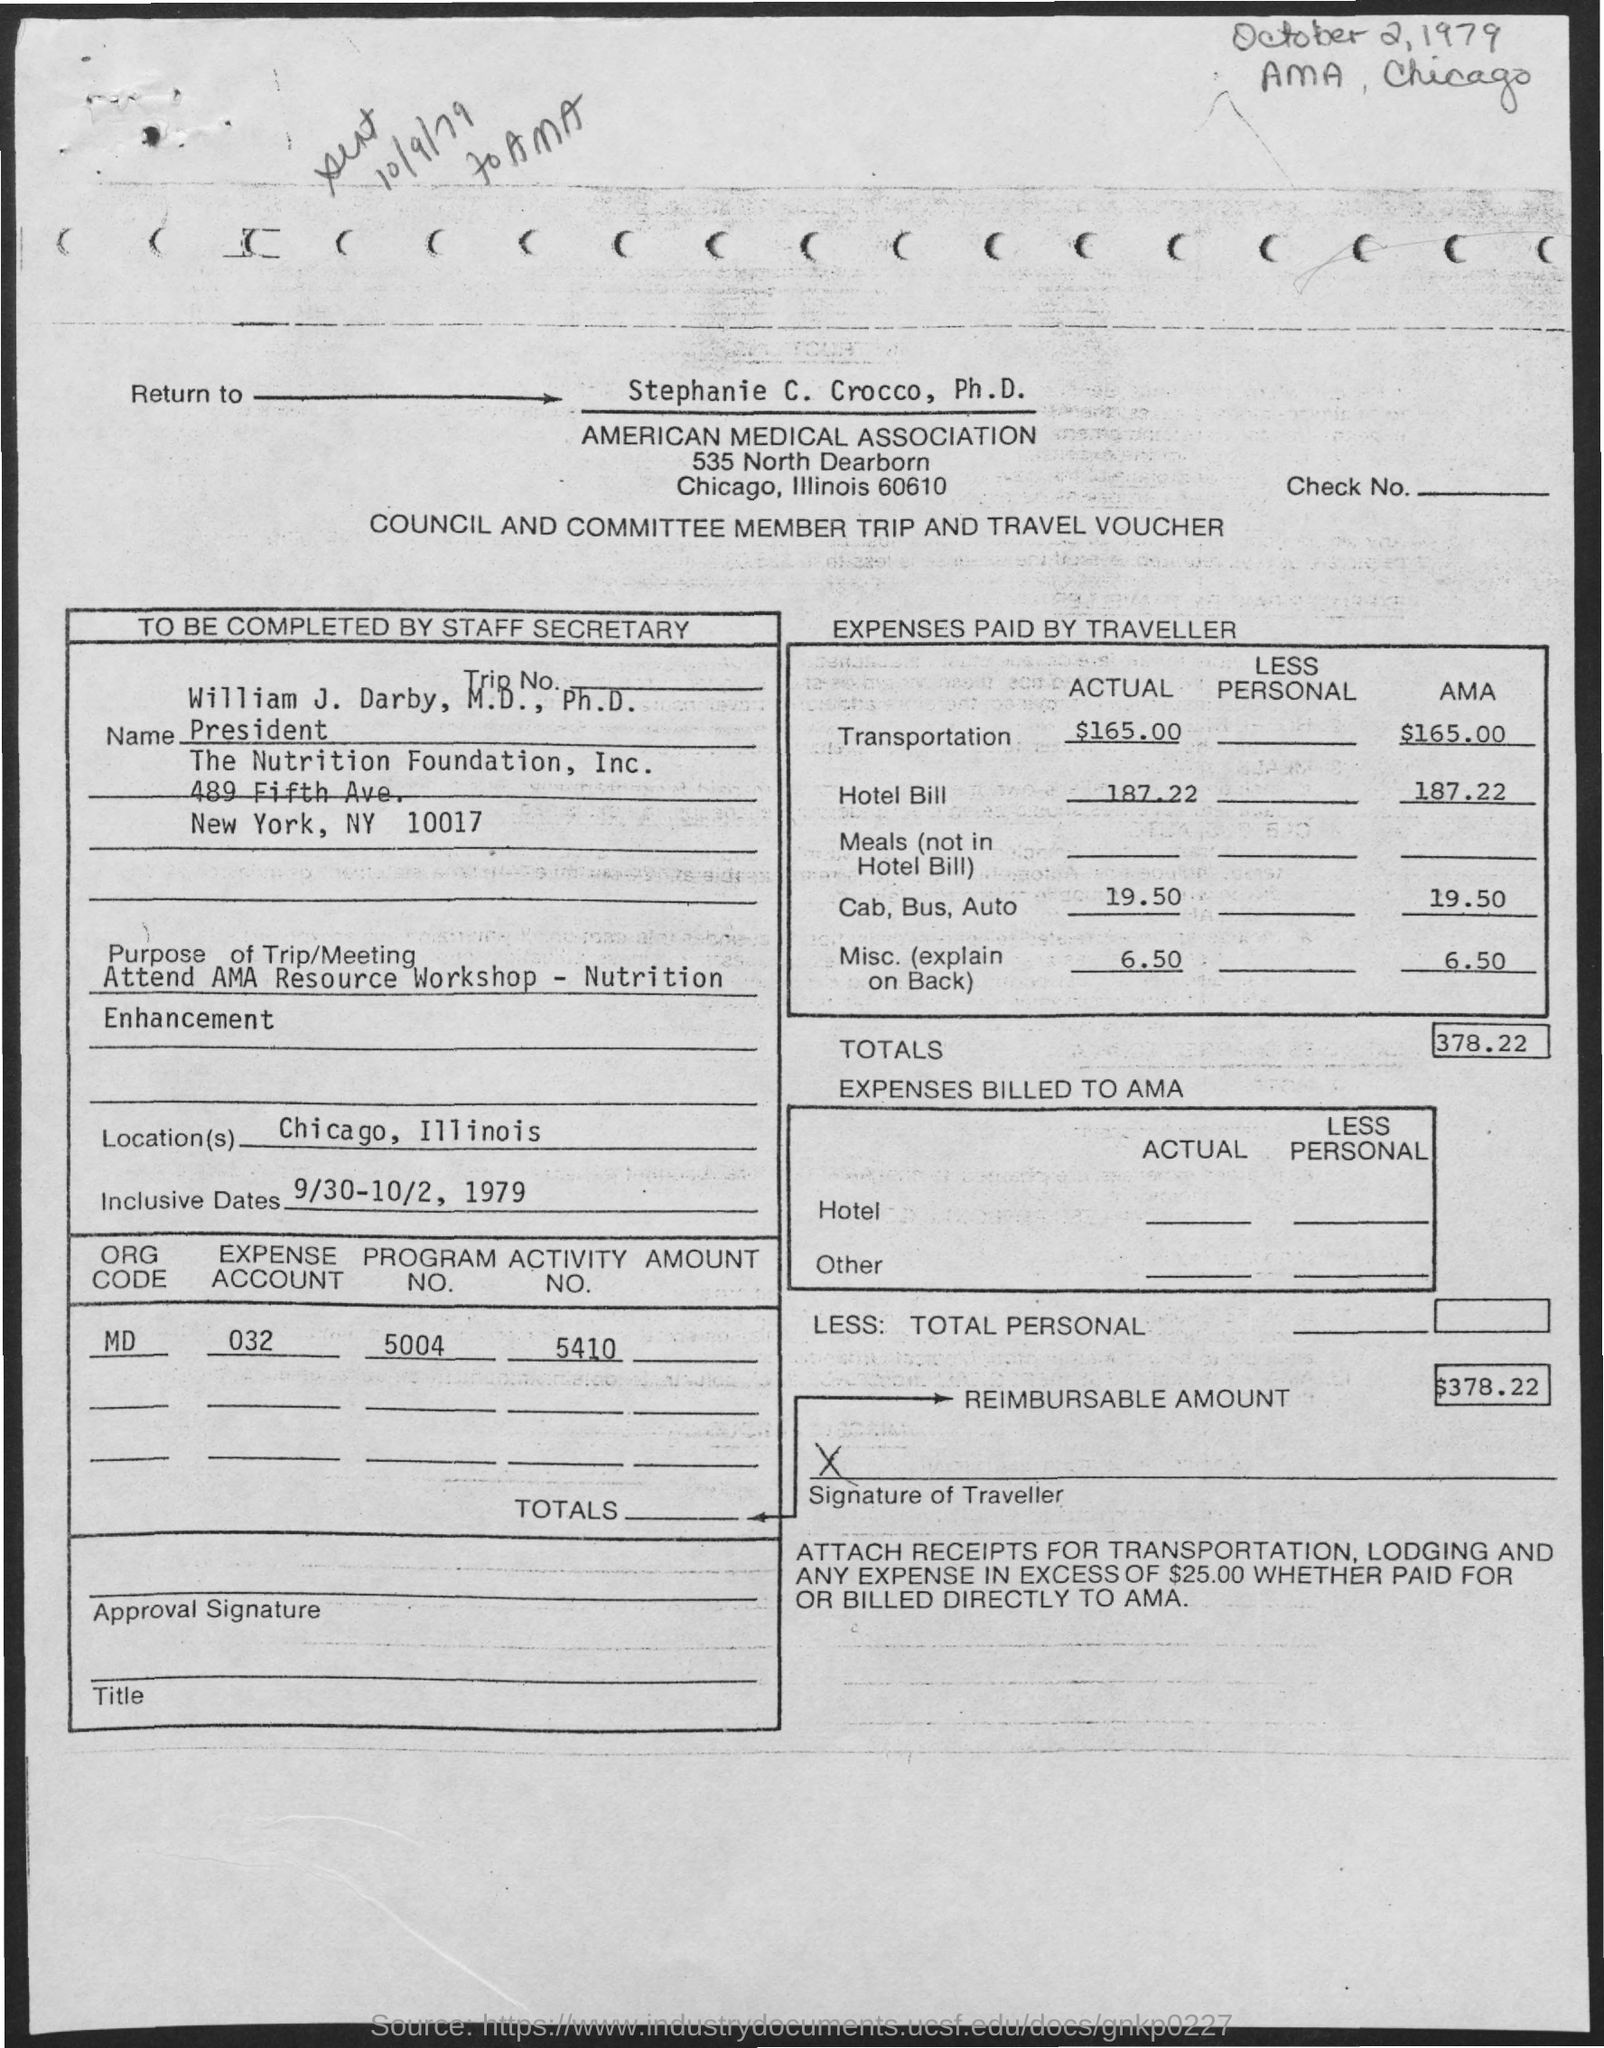What is the name of the association ?
Provide a short and direct response. AMERICAN MEDICAL ASSOCIATION. What is the designation of william  j. darby ?
Offer a terse response. PRESIDENT. What is the actual transportation expenses paid by the traveller ?
Your answer should be very brief. $ 165.00. What is the actual hotel expenses paid by the traveller ?
Make the answer very short. 187.22. What is the actual cab,bus,auto expenses paid by the traveller ?
Give a very brief answer. $ 19.50. What is the amount of  total expenses billed to ama ?
Provide a succinct answer. $ 378.22. What is the name of the location mentioned in the given form ?
Your answer should be very brief. Chicago , Illinois. What is the reimbursable amount mentioned in the given form ?
Give a very brief answer. $ 378.22. 